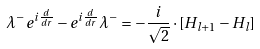Convert formula to latex. <formula><loc_0><loc_0><loc_500><loc_500>\lambda ^ { - } e ^ { i \frac { d } { d r } } - e ^ { i \frac { d } { d r } } \lambda ^ { - } = - \frac { i } { \sqrt { 2 } } \cdot [ H _ { l + 1 } - H _ { l } ]</formula> 